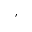<formula> <loc_0><loc_0><loc_500><loc_500>,</formula> 